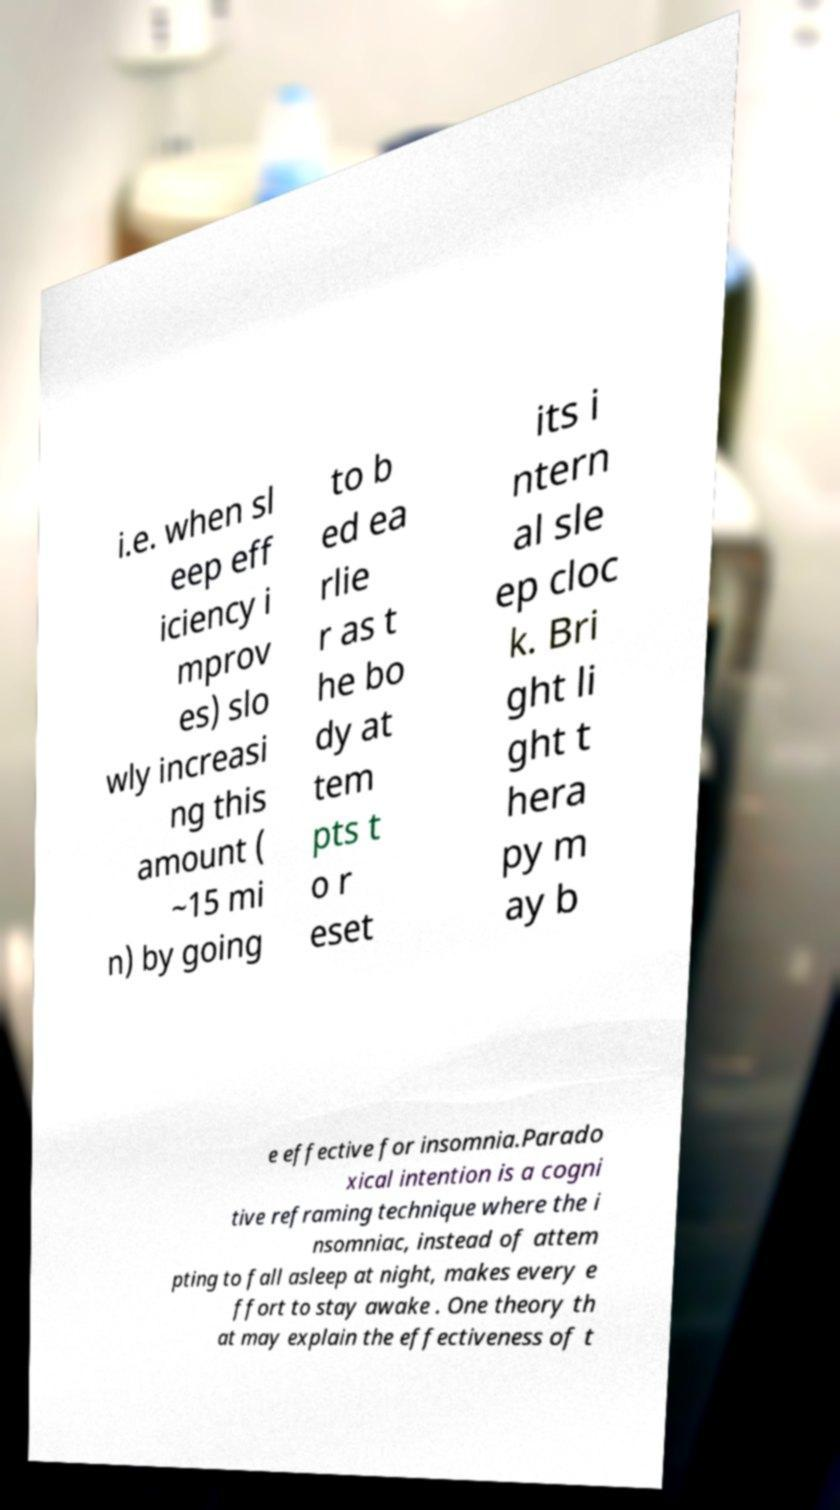Please identify and transcribe the text found in this image. i.e. when sl eep eff iciency i mprov es) slo wly increasi ng this amount ( ~15 mi n) by going to b ed ea rlie r as t he bo dy at tem pts t o r eset its i ntern al sle ep cloc k. Bri ght li ght t hera py m ay b e effective for insomnia.Parado xical intention is a cogni tive reframing technique where the i nsomniac, instead of attem pting to fall asleep at night, makes every e ffort to stay awake . One theory th at may explain the effectiveness of t 